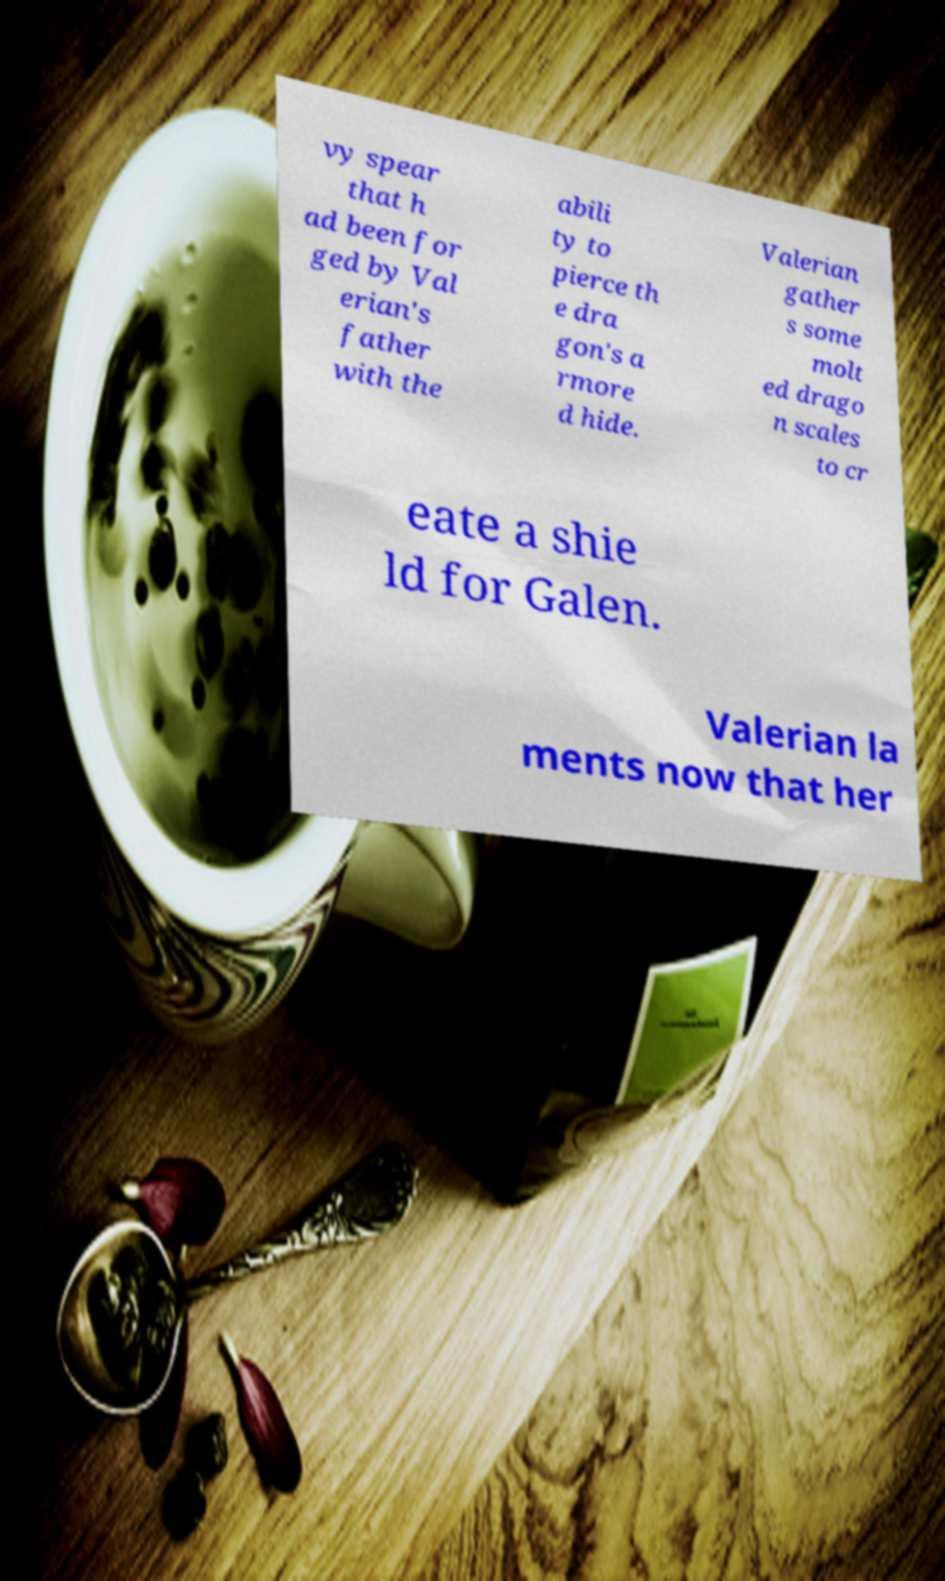Please identify and transcribe the text found in this image. vy spear that h ad been for ged by Val erian's father with the abili ty to pierce th e dra gon's a rmore d hide. Valerian gather s some molt ed drago n scales to cr eate a shie ld for Galen. Valerian la ments now that her 